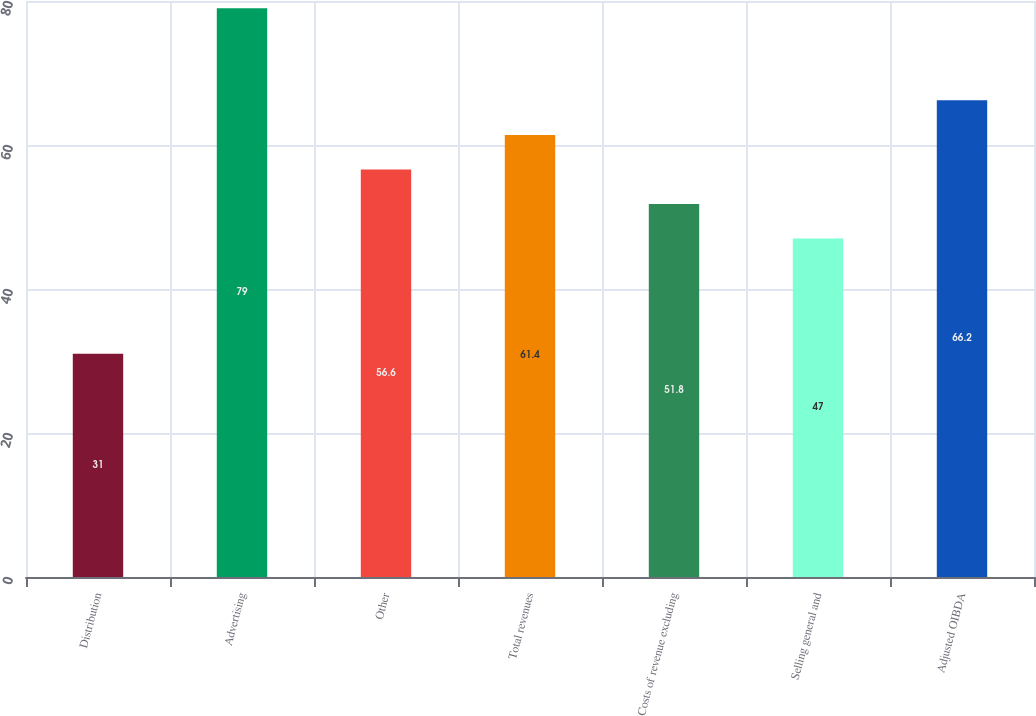<chart> <loc_0><loc_0><loc_500><loc_500><bar_chart><fcel>Distribution<fcel>Advertising<fcel>Other<fcel>Total revenues<fcel>Costs of revenue excluding<fcel>Selling general and<fcel>Adjusted OIBDA<nl><fcel>31<fcel>79<fcel>56.6<fcel>61.4<fcel>51.8<fcel>47<fcel>66.2<nl></chart> 